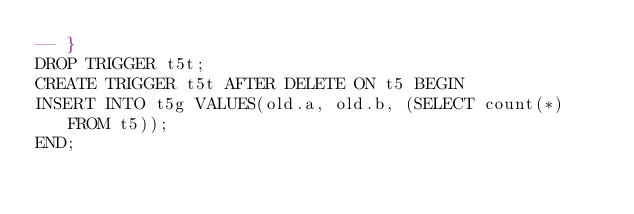Convert code to text. <code><loc_0><loc_0><loc_500><loc_500><_SQL_>-- }
DROP TRIGGER t5t;
CREATE TRIGGER t5t AFTER DELETE ON t5 BEGIN
INSERT INTO t5g VALUES(old.a, old.b, (SELECT count(*) FROM t5));
END;</code> 